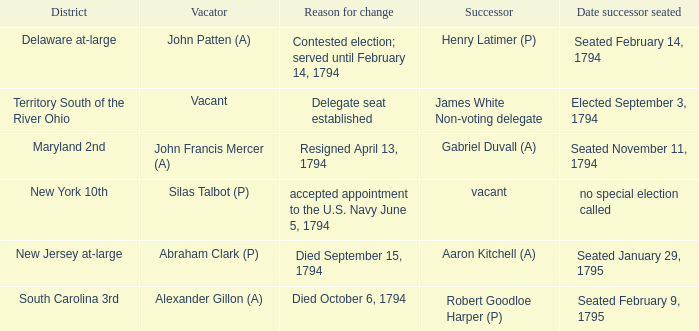Help me parse the entirety of this table. {'header': ['District', 'Vacator', 'Reason for change', 'Successor', 'Date successor seated'], 'rows': [['Delaware at-large', 'John Patten (A)', 'Contested election; served until February 14, 1794', 'Henry Latimer (P)', 'Seated February 14, 1794'], ['Territory South of the River Ohio', 'Vacant', 'Delegate seat established', 'James White Non-voting delegate', 'Elected September 3, 1794'], ['Maryland 2nd', 'John Francis Mercer (A)', 'Resigned April 13, 1794', 'Gabriel Duvall (A)', 'Seated November 11, 1794'], ['New York 10th', 'Silas Talbot (P)', 'accepted appointment to the U.S. Navy June 5, 1794', 'vacant', 'no special election called'], ['New Jersey at-large', 'Abraham Clark (P)', 'Died September 15, 1794', 'Aaron Kitchell (A)', 'Seated January 29, 1795'], ['South Carolina 3rd', 'Alexander Gillon (A)', 'Died October 6, 1794', 'Robert Goodloe Harper (P)', 'Seated February 9, 1795']]} Name the date successor seated for delegate seat established Elected September 3, 1794. 